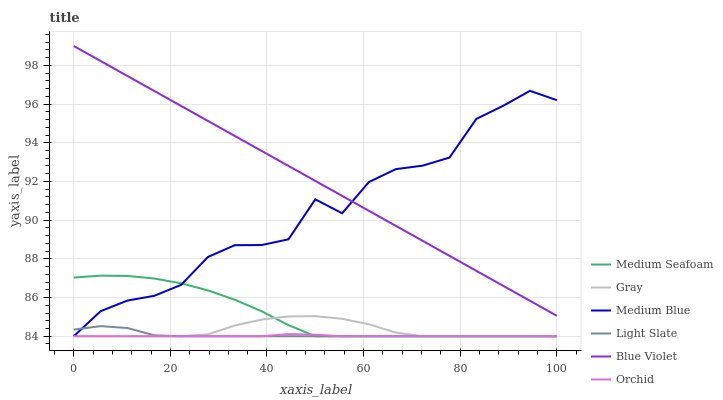Does Orchid have the minimum area under the curve?
Answer yes or no. Yes. Does Blue Violet have the maximum area under the curve?
Answer yes or no. Yes. Does Light Slate have the minimum area under the curve?
Answer yes or no. No. Does Light Slate have the maximum area under the curve?
Answer yes or no. No. Is Blue Violet the smoothest?
Answer yes or no. Yes. Is Medium Blue the roughest?
Answer yes or no. Yes. Is Light Slate the smoothest?
Answer yes or no. No. Is Light Slate the roughest?
Answer yes or no. No. Does Gray have the lowest value?
Answer yes or no. Yes. Does Blue Violet have the lowest value?
Answer yes or no. No. Does Blue Violet have the highest value?
Answer yes or no. Yes. Does Light Slate have the highest value?
Answer yes or no. No. Is Medium Seafoam less than Blue Violet?
Answer yes or no. Yes. Is Blue Violet greater than Gray?
Answer yes or no. Yes. Does Medium Blue intersect Blue Violet?
Answer yes or no. Yes. Is Medium Blue less than Blue Violet?
Answer yes or no. No. Is Medium Blue greater than Blue Violet?
Answer yes or no. No. Does Medium Seafoam intersect Blue Violet?
Answer yes or no. No. 